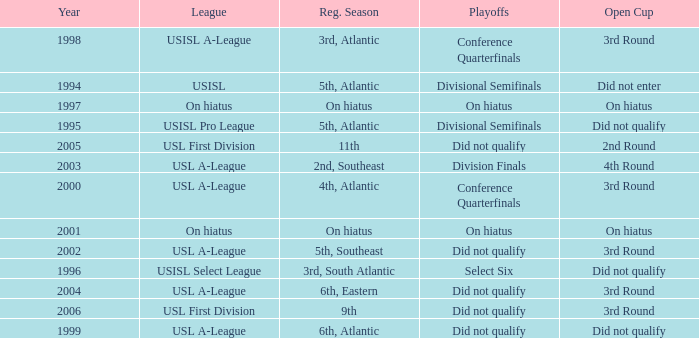When was the inaugural year of the usisl pro league? 1995.0. 